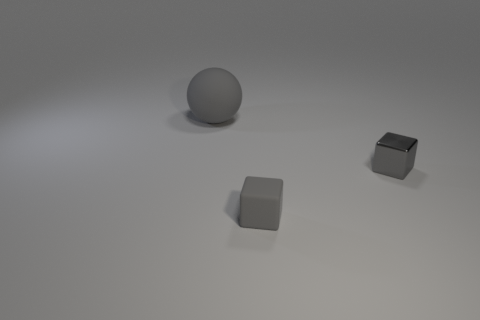Add 1 tiny blocks. How many objects exist? 4 Subtract 1 blocks. How many blocks are left? 1 Add 2 brown metal spheres. How many brown metal spheres exist? 2 Subtract 0 blue cubes. How many objects are left? 3 Subtract all balls. How many objects are left? 2 Subtract all purple blocks. Subtract all red balls. How many blocks are left? 2 Subtract all large gray rubber cubes. Subtract all cubes. How many objects are left? 1 Add 1 big gray rubber objects. How many big gray rubber objects are left? 2 